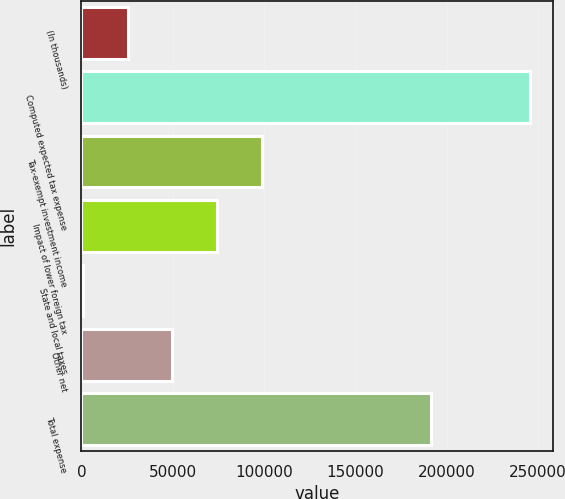Convert chart. <chart><loc_0><loc_0><loc_500><loc_500><bar_chart><fcel>(In thousands)<fcel>Computed expected tax expense<fcel>Tax-exempt investment income<fcel>Impact of lower foreign tax<fcel>State and local taxes<fcel>Other net<fcel>Total expense<nl><fcel>25245.2<fcel>245675<fcel>98721.8<fcel>74229.6<fcel>753<fcel>49737.4<fcel>191285<nl></chart> 